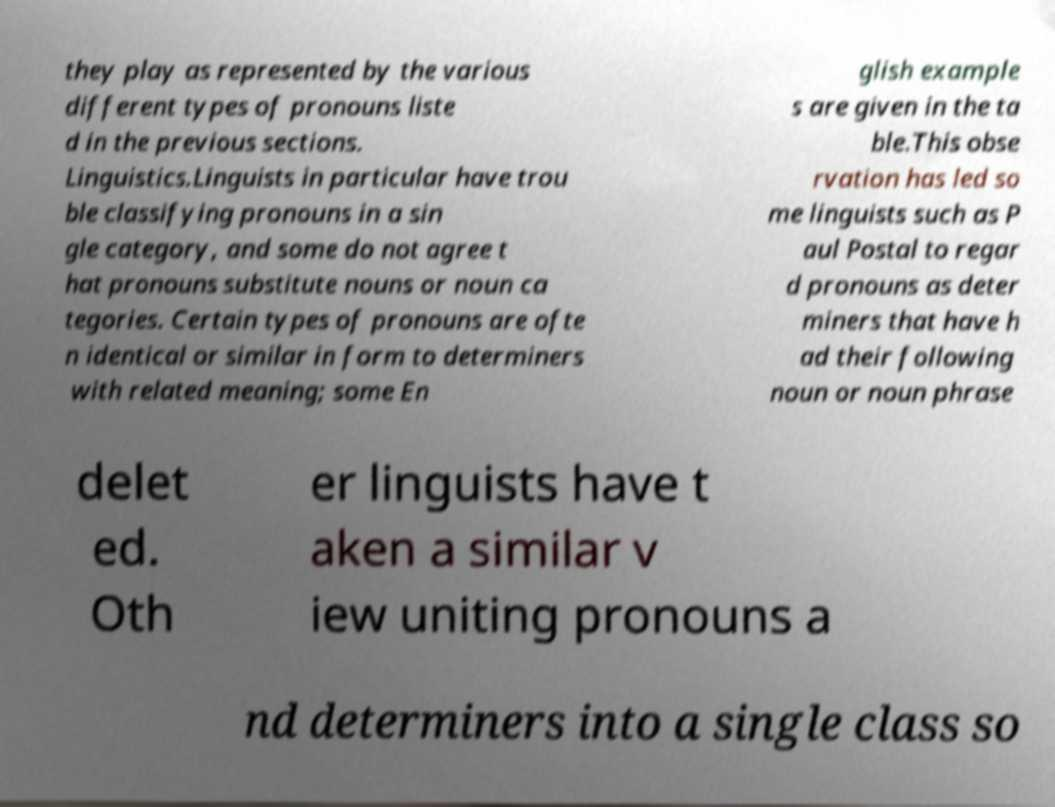I need the written content from this picture converted into text. Can you do that? they play as represented by the various different types of pronouns liste d in the previous sections. Linguistics.Linguists in particular have trou ble classifying pronouns in a sin gle category, and some do not agree t hat pronouns substitute nouns or noun ca tegories. Certain types of pronouns are ofte n identical or similar in form to determiners with related meaning; some En glish example s are given in the ta ble.This obse rvation has led so me linguists such as P aul Postal to regar d pronouns as deter miners that have h ad their following noun or noun phrase delet ed. Oth er linguists have t aken a similar v iew uniting pronouns a nd determiners into a single class so 